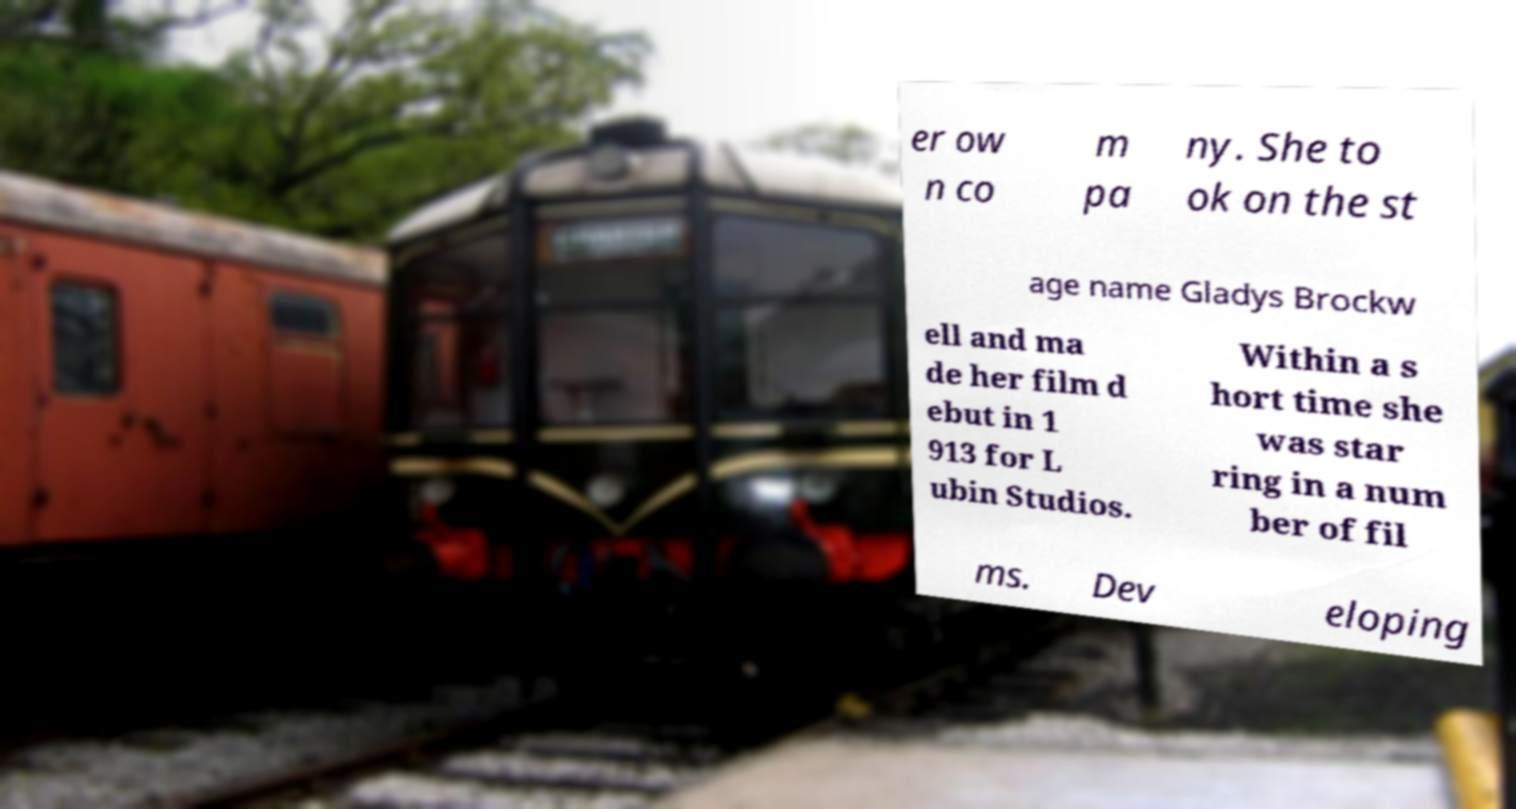Could you assist in decoding the text presented in this image and type it out clearly? er ow n co m pa ny. She to ok on the st age name Gladys Brockw ell and ma de her film d ebut in 1 913 for L ubin Studios. Within a s hort time she was star ring in a num ber of fil ms. Dev eloping 